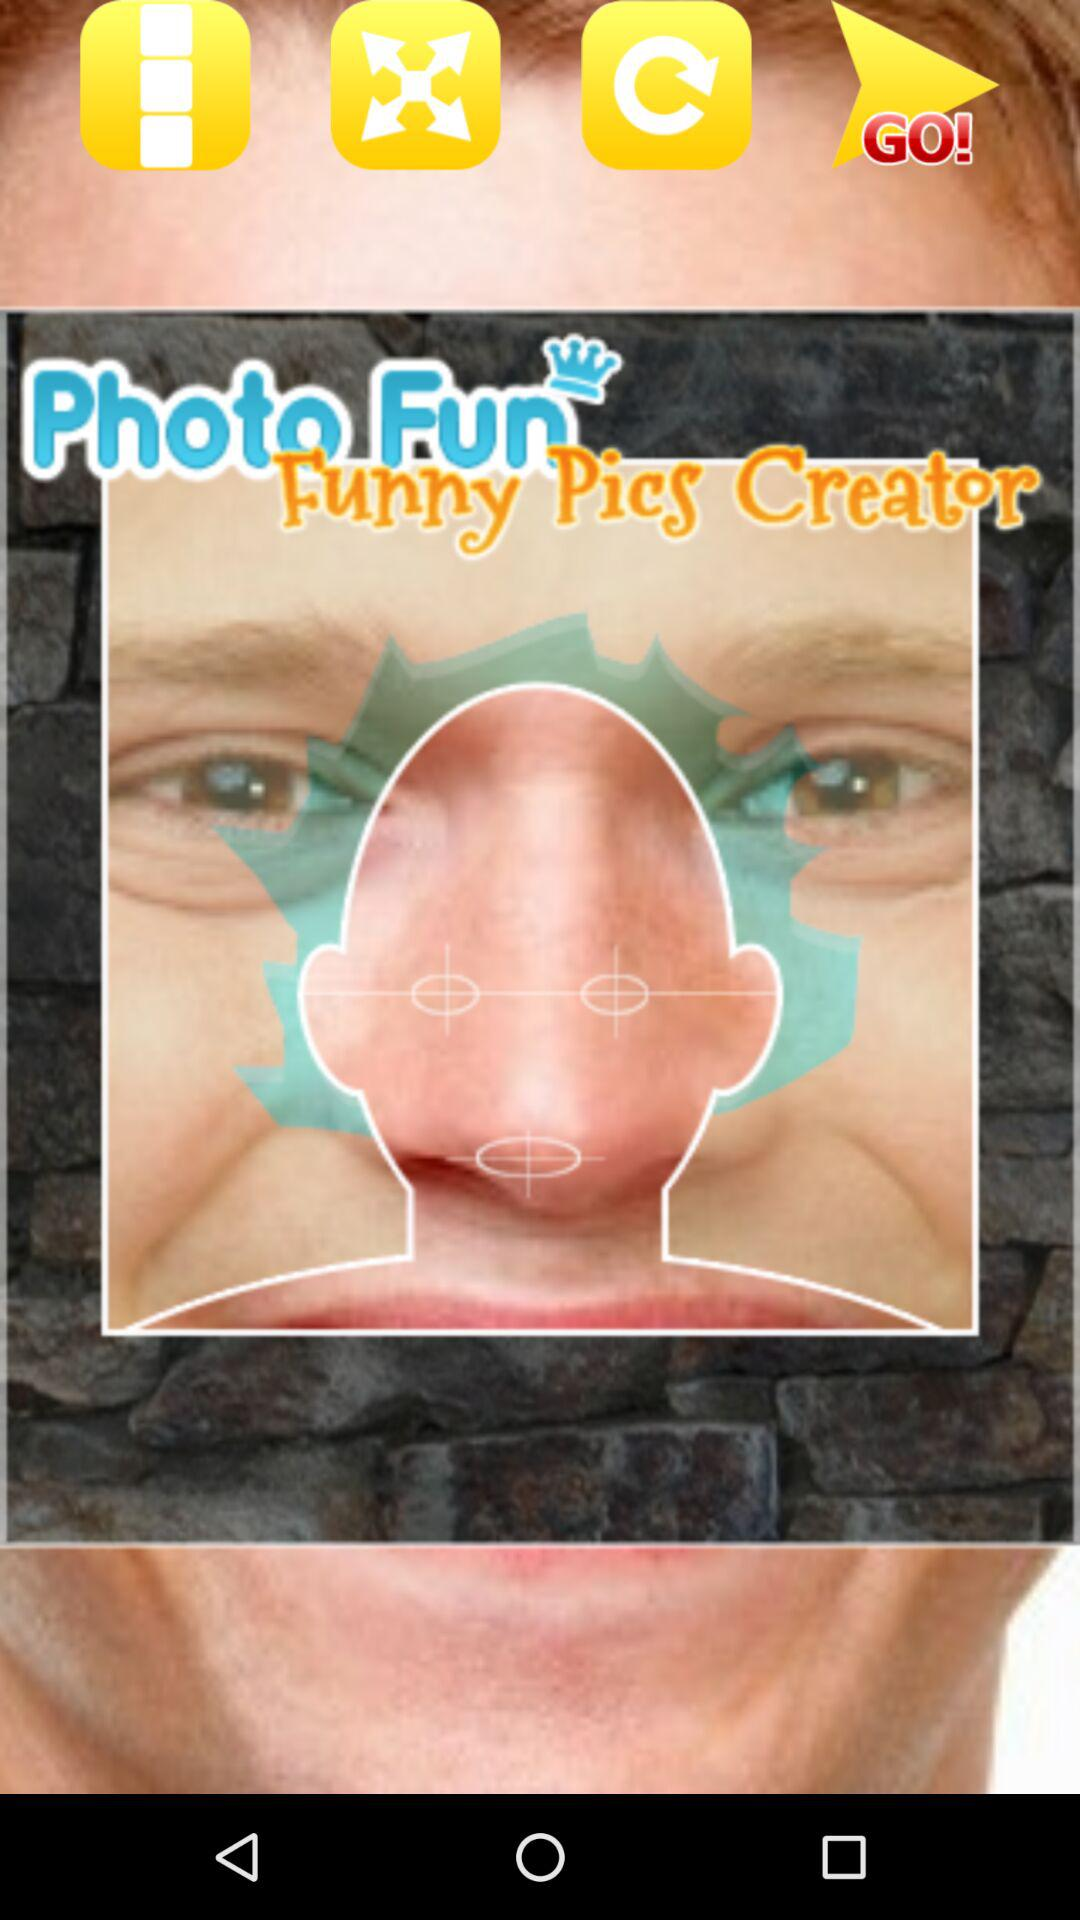What is the application name? The application name is "Photo Fun Funny Pics Creator". 